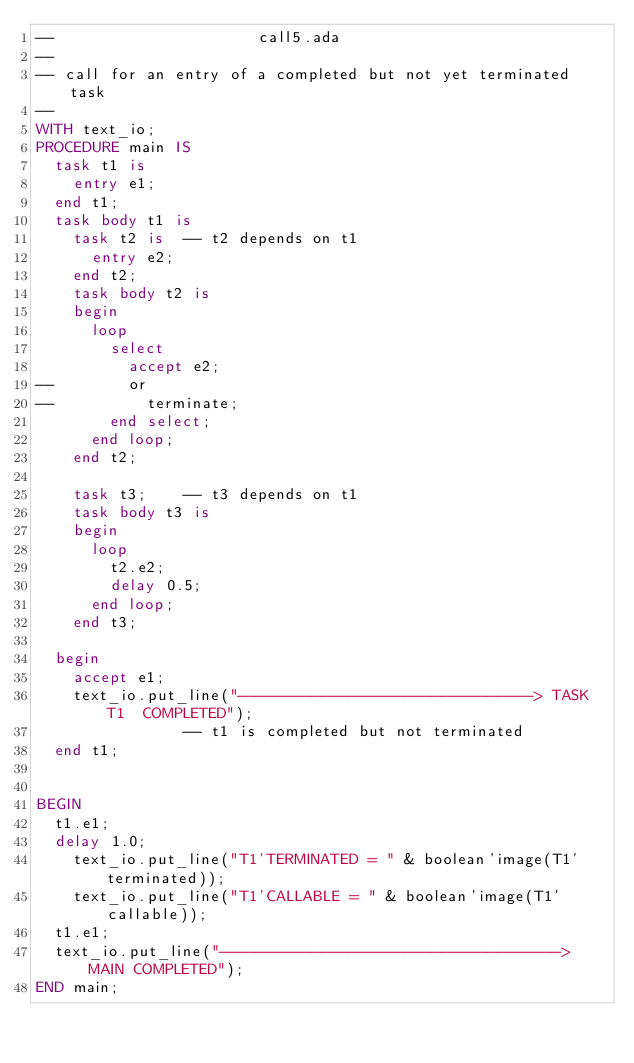Convert code to text. <code><loc_0><loc_0><loc_500><loc_500><_Ada_>--                      call5.ada
--
-- call for an entry of a completed but not yet terminated task
--
WITH text_io;
PROCEDURE main IS
  task t1 is
    entry e1;
  end t1;
  task body t1 is
    task t2 is  -- t2 depends on t1
      entry e2;
    end t2;
    task body t2 is
    begin
      loop
        select
          accept e2;
--        or
--          terminate;
        end select;
      end loop;
    end t2;

    task t3;    -- t3 depends on t1
    task body t3 is
    begin
      loop
        t2.e2;
        delay 0.5;
      end loop;
    end t3;

  begin
    accept e1;
    text_io.put_line("--------------------------------> TASK T1  COMPLETED");
                -- t1 is completed but not terminated
  end t1;


BEGIN
  t1.e1;
  delay 1.0;
    text_io.put_line("T1'TERMINATED = " & boolean'image(T1'terminated));
    text_io.put_line("T1'CALLABLE = " & boolean'image(T1'callable));
  t1.e1;
  text_io.put_line("-------------------------------------> MAIN COMPLETED");
END main;
</code> 